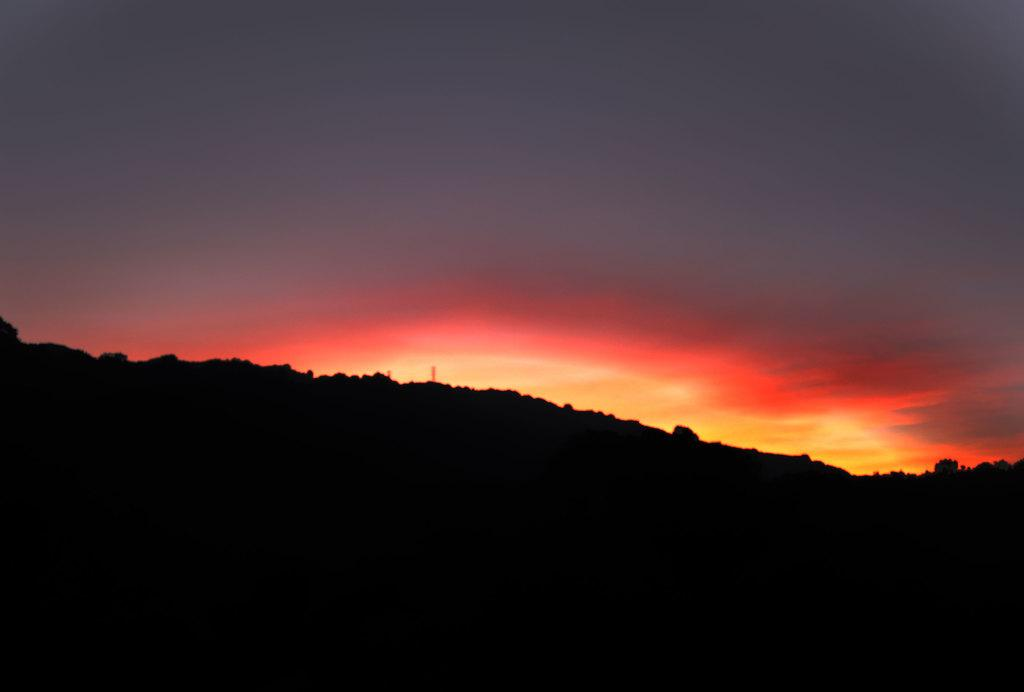What can be observed at the bottom of the image? The bottom of the image is dark, and there are shadows of trees and hills in this area. What is visible in the background of the image? The sky is visible in the background. How would you describe the color of the sky in the image? The sky is dark and in grey color, with an orange hue. What type of veil is draped over the trees in the image? There is no veil present in the image; the trees are casting shadows in the dark area at the bottom of the image. Can you see any lips in the image? There are no lips visible in the image. 